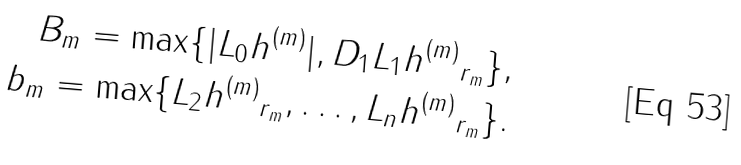Convert formula to latex. <formula><loc_0><loc_0><loc_500><loc_500>B _ { m } = \max \{ | L _ { 0 } h ^ { ( m ) } | , \| D _ { 1 } L _ { 1 } h ^ { ( m ) } \| _ { r _ { m } } \} , \\ b _ { m } = \max \{ \| L _ { 2 } h ^ { ( m ) } \| _ { r _ { m } } , \dots , \| L _ { n } h ^ { ( m ) } \| _ { r _ { m } } \} .</formula> 